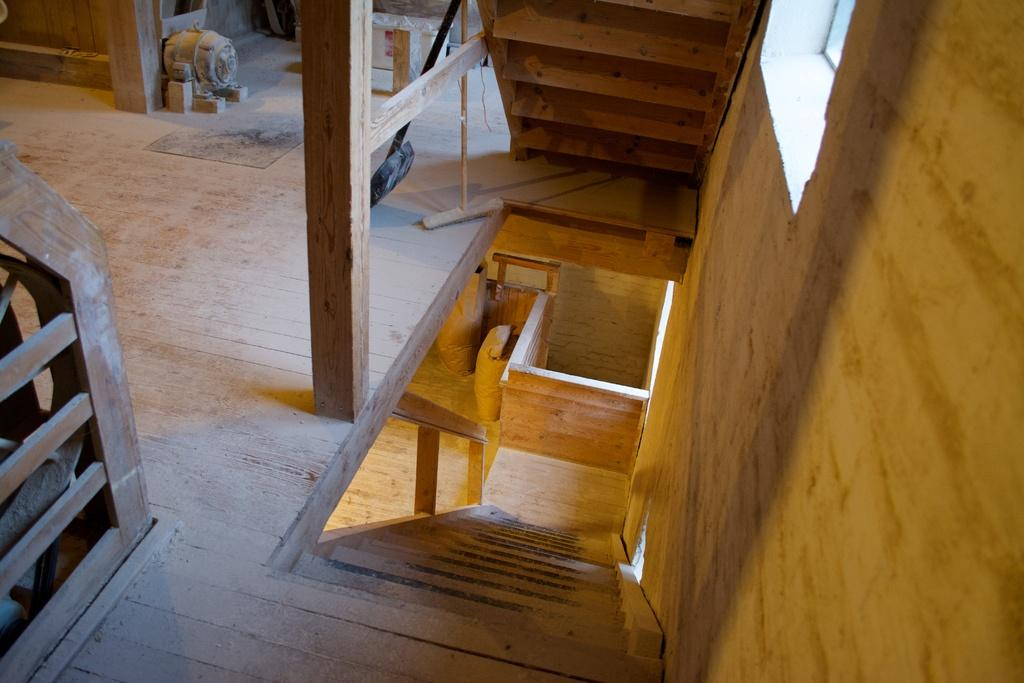What type of structure is shown in the image? The image is of the inside part of a wooden house. What architectural feature can be seen in the image? There is a staircase in the image. What type of flower is on the kettle in the image? There is no flower or kettle present in the image. How many ants can be seen crawling on the staircase in the image? There are no ants visible in the image. 